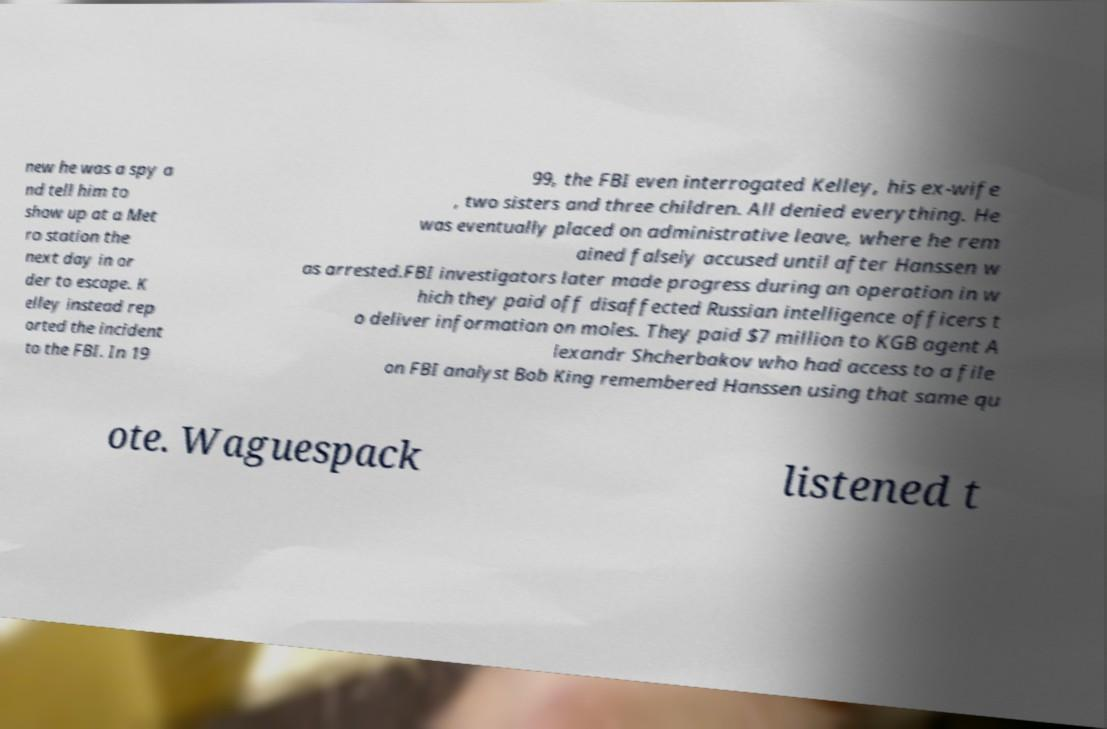There's text embedded in this image that I need extracted. Can you transcribe it verbatim? new he was a spy a nd tell him to show up at a Met ro station the next day in or der to escape. K elley instead rep orted the incident to the FBI. In 19 99, the FBI even interrogated Kelley, his ex-wife , two sisters and three children. All denied everything. He was eventually placed on administrative leave, where he rem ained falsely accused until after Hanssen w as arrested.FBI investigators later made progress during an operation in w hich they paid off disaffected Russian intelligence officers t o deliver information on moles. They paid $7 million to KGB agent A lexandr Shcherbakov who had access to a file on FBI analyst Bob King remembered Hanssen using that same qu ote. Waguespack listened t 